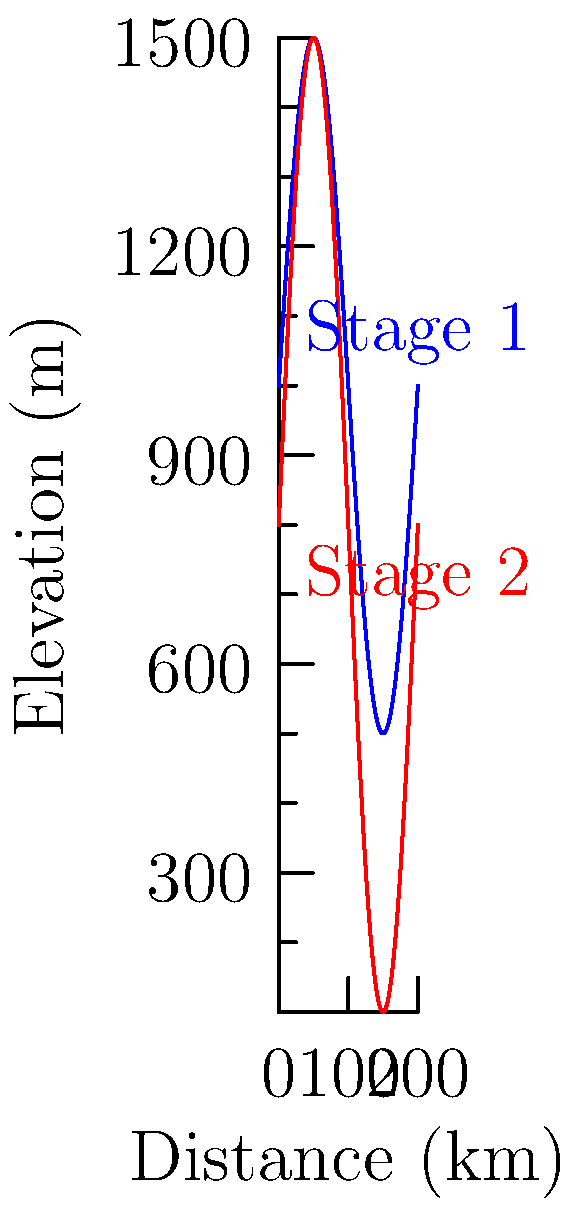Compare the elevation profiles of Stage 1 (blue) and Stage 2 (red) in the graph above. Which stage has a higher total elevation gain and is likely to be more challenging for cyclists? To determine which stage has a higher total elevation gain and is likely more challenging, we need to analyze the elevation profiles:

1. Observe the y-axis (Elevation):
   - Stage 1 (blue) ranges from approximately 500m to 1500m.
   - Stage 2 (red) ranges from approximately 100m to 1500m.

2. Calculate the elevation range:
   - Stage 1: 1500m - 500m = 1000m
   - Stage 2: 1500m - 100m = 1400m

3. Compare the number of climbs:
   - Both stages appear to have two major climbs.

4. Analyze the steepness of climbs:
   - Stage 2 shows steeper gradients, as evidenced by the sharper peaks.

5. Consider the starting and finishing elevations:
   - Stage 2 starts at a lower elevation and reaches the same maximum as Stage 1.

Given these observations, Stage 2 (red) has a higher total elevation gain of 1400m compared to Stage 1's 1000m. The steeper gradients and lower starting point of Stage 2 make it likely to be more challenging for cyclists.
Answer: Stage 2 (red) 